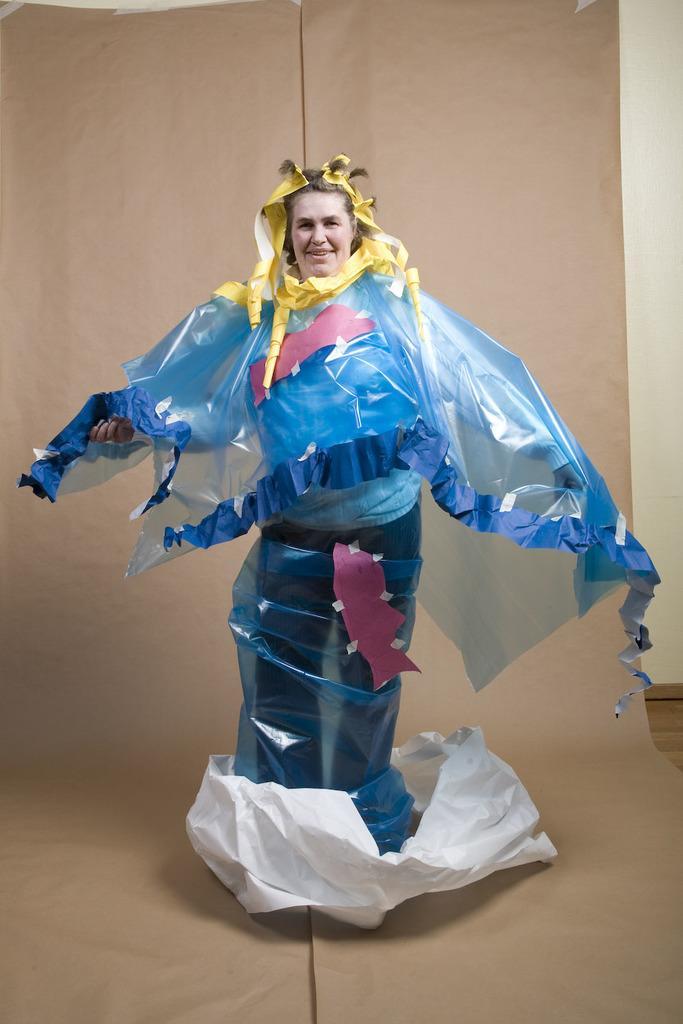Can you describe this image briefly? In this image there is a person standing on the cover. At the bottom of the image there is a mat on the floor. In the background of the image there is a wall. 